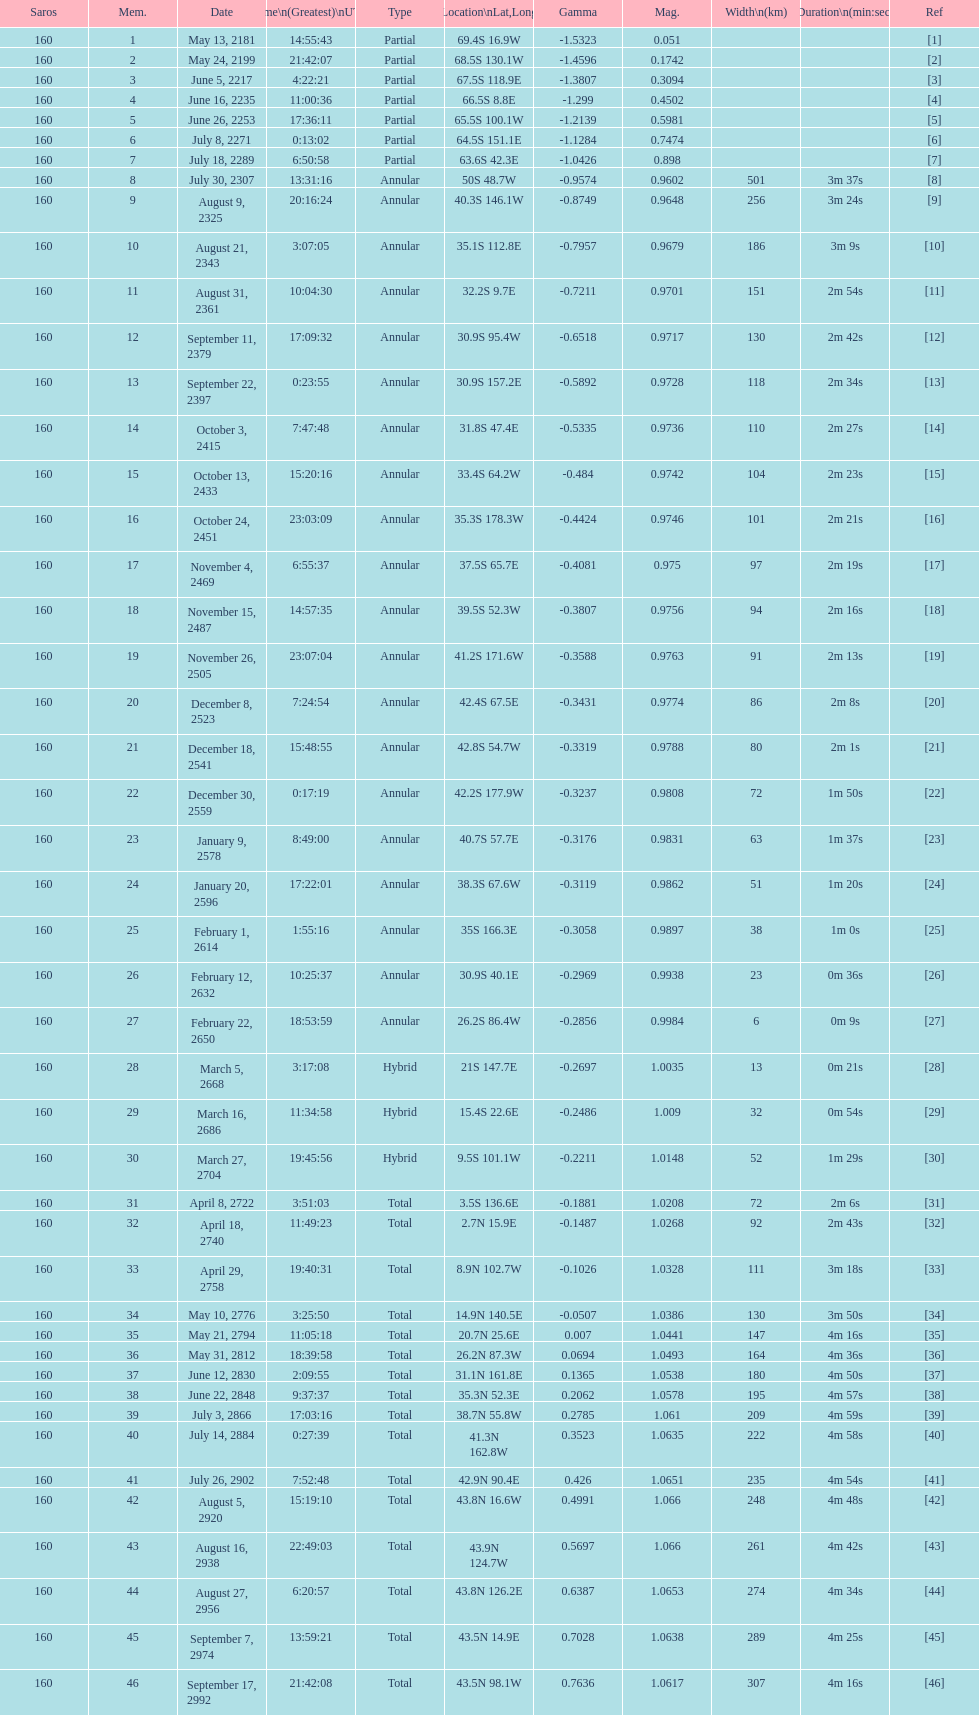How many solar saros events lasted longer than 4 minutes? 12. 